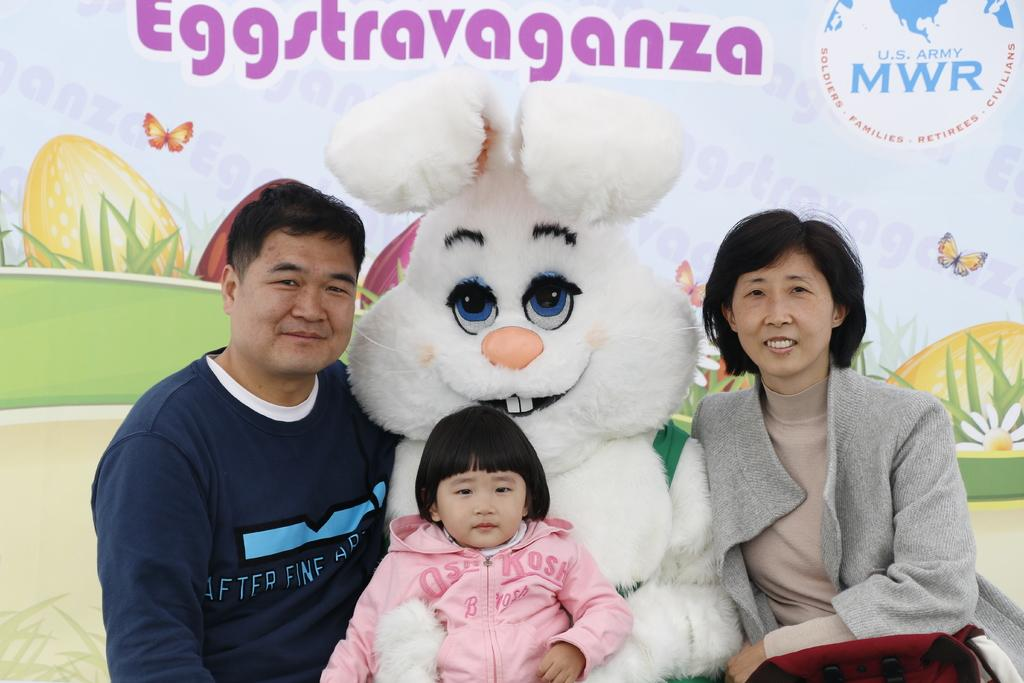How many people are present in the image? There are two people, a man and a woman, present in the image. What else can be seen in the image besides the people? There is a baby in the image, and the baby is standing on a rabbit toy. What is on the wall in the image? There is a banner on the wall in the image. What type of space technology is visible in the image? There is no space technology present in the image. Can you describe the connection between the baby and the rat in the image? There is no rat present in the image, and the baby is standing on a rabbit toy, not a rat. 